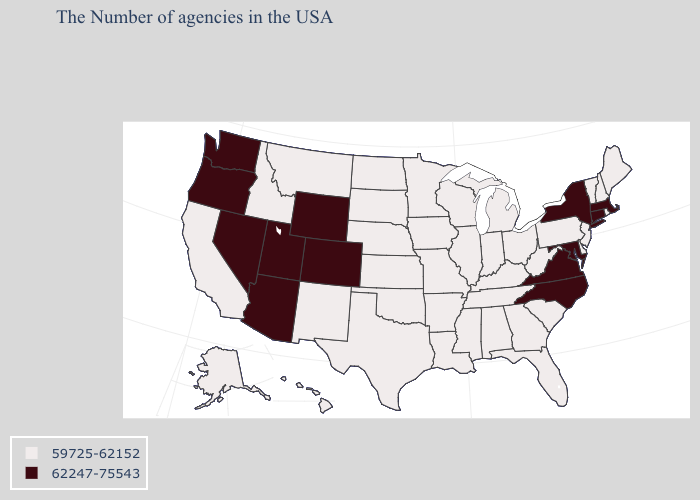What is the value of Florida?
Keep it brief. 59725-62152. What is the lowest value in the USA?
Short answer required. 59725-62152. Among the states that border Alabama , which have the lowest value?
Concise answer only. Florida, Georgia, Tennessee, Mississippi. Does the map have missing data?
Keep it brief. No. What is the value of Oregon?
Write a very short answer. 62247-75543. Name the states that have a value in the range 62247-75543?
Give a very brief answer. Massachusetts, Connecticut, New York, Maryland, Virginia, North Carolina, Wyoming, Colorado, Utah, Arizona, Nevada, Washington, Oregon. Name the states that have a value in the range 59725-62152?
Answer briefly. Maine, Rhode Island, New Hampshire, Vermont, New Jersey, Delaware, Pennsylvania, South Carolina, West Virginia, Ohio, Florida, Georgia, Michigan, Kentucky, Indiana, Alabama, Tennessee, Wisconsin, Illinois, Mississippi, Louisiana, Missouri, Arkansas, Minnesota, Iowa, Kansas, Nebraska, Oklahoma, Texas, South Dakota, North Dakota, New Mexico, Montana, Idaho, California, Alaska, Hawaii. What is the lowest value in the West?
Give a very brief answer. 59725-62152. Among the states that border New York , does Massachusetts have the lowest value?
Concise answer only. No. What is the value of Kansas?
Answer briefly. 59725-62152. Among the states that border Massachusetts , which have the lowest value?
Quick response, please. Rhode Island, New Hampshire, Vermont. Does Vermont have the lowest value in the Northeast?
Write a very short answer. Yes. What is the highest value in the USA?
Quick response, please. 62247-75543. 